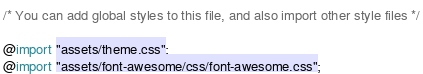Convert code to text. <code><loc_0><loc_0><loc_500><loc_500><_CSS_>/* You can add global styles to this file, and also import other style files */

@import "assets/theme.css";
@import "assets/font-awesome/css/font-awesome.css";</code> 